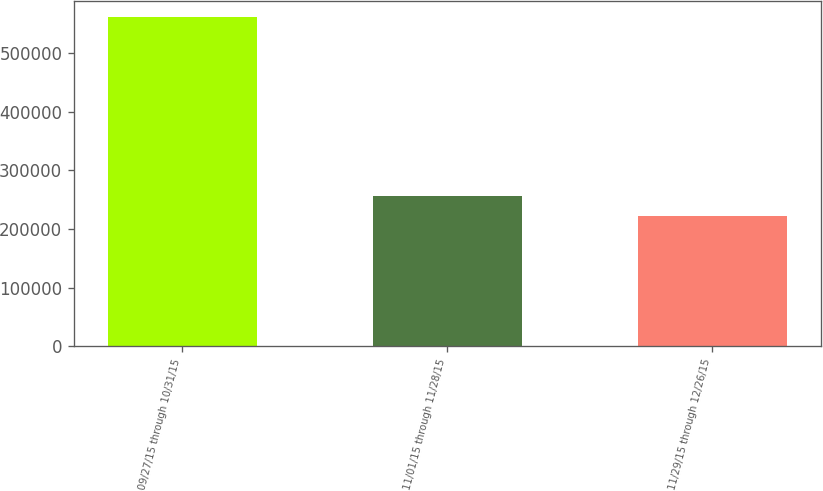<chart> <loc_0><loc_0><loc_500><loc_500><bar_chart><fcel>09/27/15 through 10/31/15<fcel>11/01/15 through 11/28/15<fcel>11/29/15 through 12/26/15<nl><fcel>560638<fcel>255864<fcel>222000<nl></chart> 